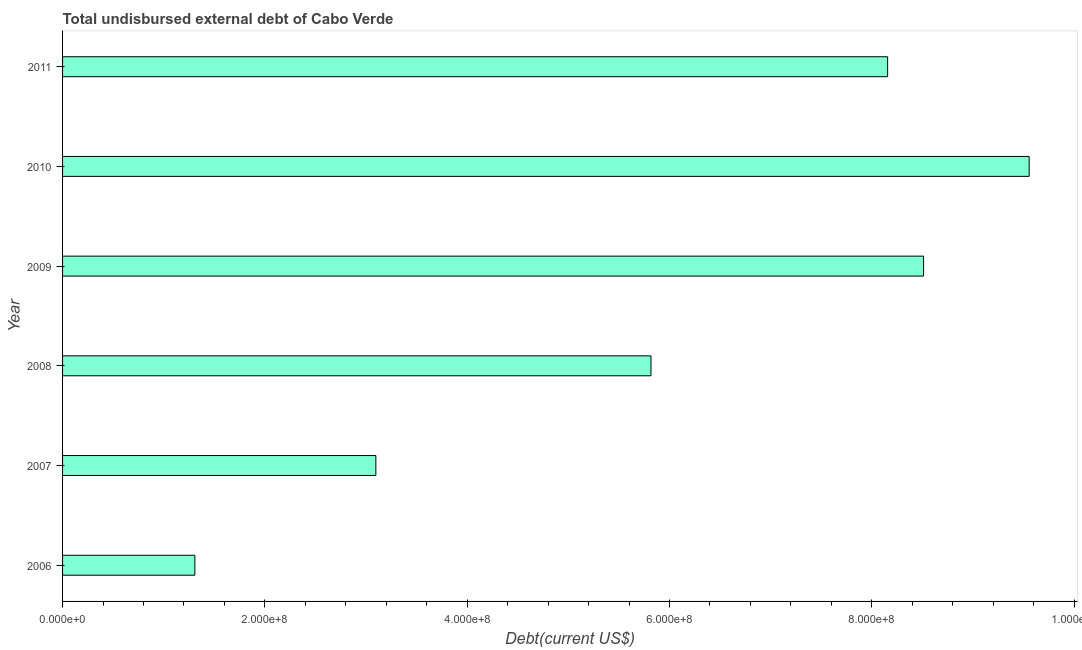Does the graph contain any zero values?
Keep it short and to the point. No. What is the title of the graph?
Offer a terse response. Total undisbursed external debt of Cabo Verde. What is the label or title of the X-axis?
Give a very brief answer. Debt(current US$). What is the label or title of the Y-axis?
Make the answer very short. Year. What is the total debt in 2008?
Provide a short and direct response. 5.82e+08. Across all years, what is the maximum total debt?
Offer a terse response. 9.56e+08. Across all years, what is the minimum total debt?
Your response must be concise. 1.31e+08. In which year was the total debt maximum?
Give a very brief answer. 2010. In which year was the total debt minimum?
Make the answer very short. 2006. What is the sum of the total debt?
Your response must be concise. 3.64e+09. What is the difference between the total debt in 2006 and 2007?
Your answer should be very brief. -1.79e+08. What is the average total debt per year?
Your answer should be very brief. 6.07e+08. What is the median total debt?
Make the answer very short. 6.99e+08. Do a majority of the years between 2006 and 2011 (inclusive) have total debt greater than 440000000 US$?
Give a very brief answer. Yes. What is the ratio of the total debt in 2006 to that in 2010?
Offer a very short reply. 0.14. Is the total debt in 2006 less than that in 2009?
Keep it short and to the point. Yes. What is the difference between the highest and the second highest total debt?
Provide a short and direct response. 1.04e+08. Is the sum of the total debt in 2008 and 2011 greater than the maximum total debt across all years?
Provide a succinct answer. Yes. What is the difference between the highest and the lowest total debt?
Offer a terse response. 8.25e+08. How many bars are there?
Make the answer very short. 6. How many years are there in the graph?
Provide a succinct answer. 6. What is the difference between two consecutive major ticks on the X-axis?
Make the answer very short. 2.00e+08. Are the values on the major ticks of X-axis written in scientific E-notation?
Keep it short and to the point. Yes. What is the Debt(current US$) of 2006?
Give a very brief answer. 1.31e+08. What is the Debt(current US$) of 2007?
Your answer should be compact. 3.10e+08. What is the Debt(current US$) in 2008?
Provide a short and direct response. 5.82e+08. What is the Debt(current US$) of 2009?
Provide a succinct answer. 8.51e+08. What is the Debt(current US$) of 2010?
Your response must be concise. 9.56e+08. What is the Debt(current US$) in 2011?
Provide a succinct answer. 8.16e+08. What is the difference between the Debt(current US$) in 2006 and 2007?
Give a very brief answer. -1.79e+08. What is the difference between the Debt(current US$) in 2006 and 2008?
Provide a succinct answer. -4.51e+08. What is the difference between the Debt(current US$) in 2006 and 2009?
Your response must be concise. -7.20e+08. What is the difference between the Debt(current US$) in 2006 and 2010?
Offer a terse response. -8.25e+08. What is the difference between the Debt(current US$) in 2006 and 2011?
Offer a very short reply. -6.85e+08. What is the difference between the Debt(current US$) in 2007 and 2008?
Your answer should be compact. -2.72e+08. What is the difference between the Debt(current US$) in 2007 and 2009?
Keep it short and to the point. -5.41e+08. What is the difference between the Debt(current US$) in 2007 and 2010?
Your answer should be compact. -6.46e+08. What is the difference between the Debt(current US$) in 2007 and 2011?
Give a very brief answer. -5.06e+08. What is the difference between the Debt(current US$) in 2008 and 2009?
Provide a short and direct response. -2.69e+08. What is the difference between the Debt(current US$) in 2008 and 2010?
Offer a very short reply. -3.74e+08. What is the difference between the Debt(current US$) in 2008 and 2011?
Provide a succinct answer. -2.34e+08. What is the difference between the Debt(current US$) in 2009 and 2010?
Keep it short and to the point. -1.04e+08. What is the difference between the Debt(current US$) in 2009 and 2011?
Keep it short and to the point. 3.55e+07. What is the difference between the Debt(current US$) in 2010 and 2011?
Keep it short and to the point. 1.40e+08. What is the ratio of the Debt(current US$) in 2006 to that in 2007?
Ensure brevity in your answer.  0.42. What is the ratio of the Debt(current US$) in 2006 to that in 2008?
Ensure brevity in your answer.  0.23. What is the ratio of the Debt(current US$) in 2006 to that in 2009?
Offer a terse response. 0.15. What is the ratio of the Debt(current US$) in 2006 to that in 2010?
Offer a terse response. 0.14. What is the ratio of the Debt(current US$) in 2006 to that in 2011?
Your answer should be very brief. 0.16. What is the ratio of the Debt(current US$) in 2007 to that in 2008?
Your answer should be compact. 0.53. What is the ratio of the Debt(current US$) in 2007 to that in 2009?
Your response must be concise. 0.36. What is the ratio of the Debt(current US$) in 2007 to that in 2010?
Your answer should be very brief. 0.32. What is the ratio of the Debt(current US$) in 2007 to that in 2011?
Offer a terse response. 0.38. What is the ratio of the Debt(current US$) in 2008 to that in 2009?
Provide a succinct answer. 0.68. What is the ratio of the Debt(current US$) in 2008 to that in 2010?
Provide a succinct answer. 0.61. What is the ratio of the Debt(current US$) in 2008 to that in 2011?
Provide a short and direct response. 0.71. What is the ratio of the Debt(current US$) in 2009 to that in 2010?
Offer a terse response. 0.89. What is the ratio of the Debt(current US$) in 2009 to that in 2011?
Offer a very short reply. 1.04. What is the ratio of the Debt(current US$) in 2010 to that in 2011?
Make the answer very short. 1.17. 